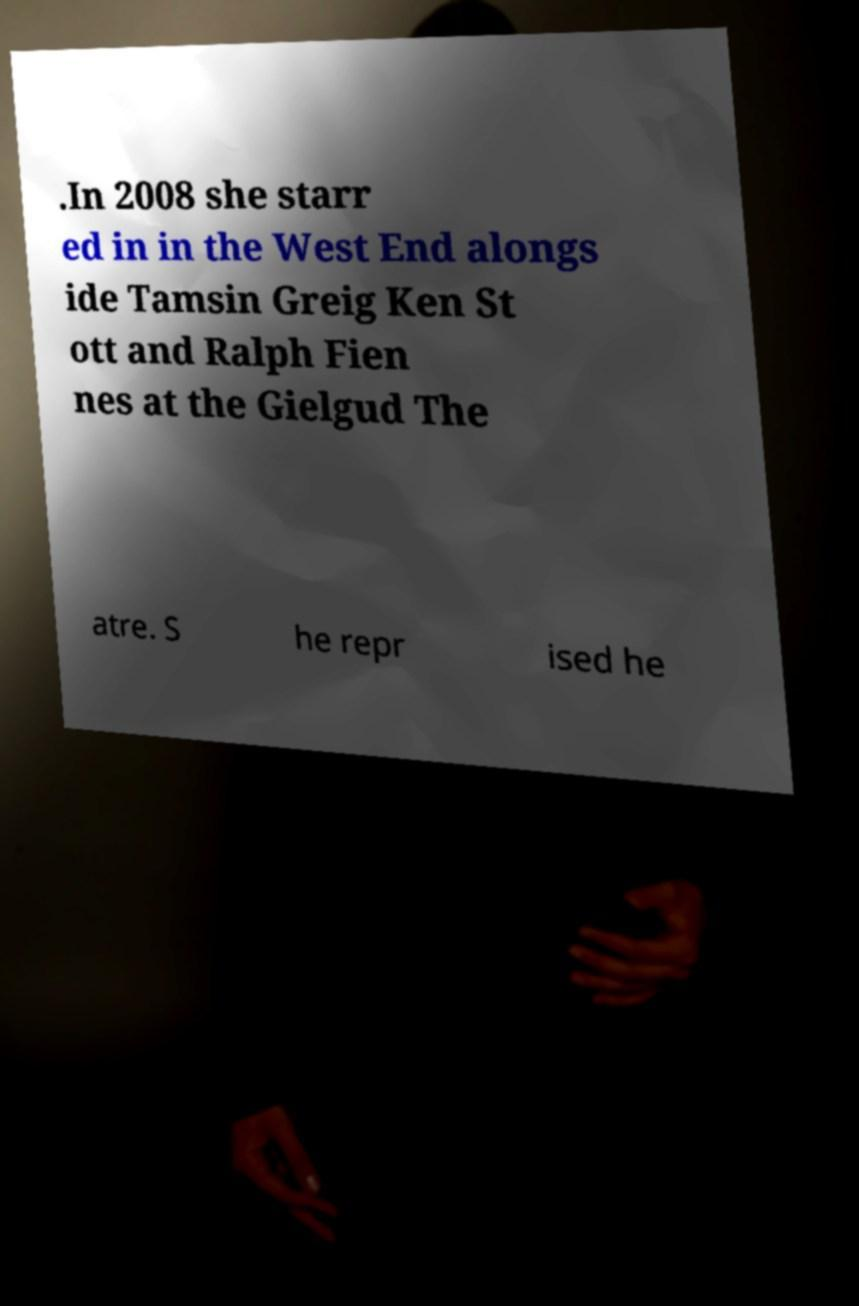Could you extract and type out the text from this image? .In 2008 she starr ed in in the West End alongs ide Tamsin Greig Ken St ott and Ralph Fien nes at the Gielgud The atre. S he repr ised he 